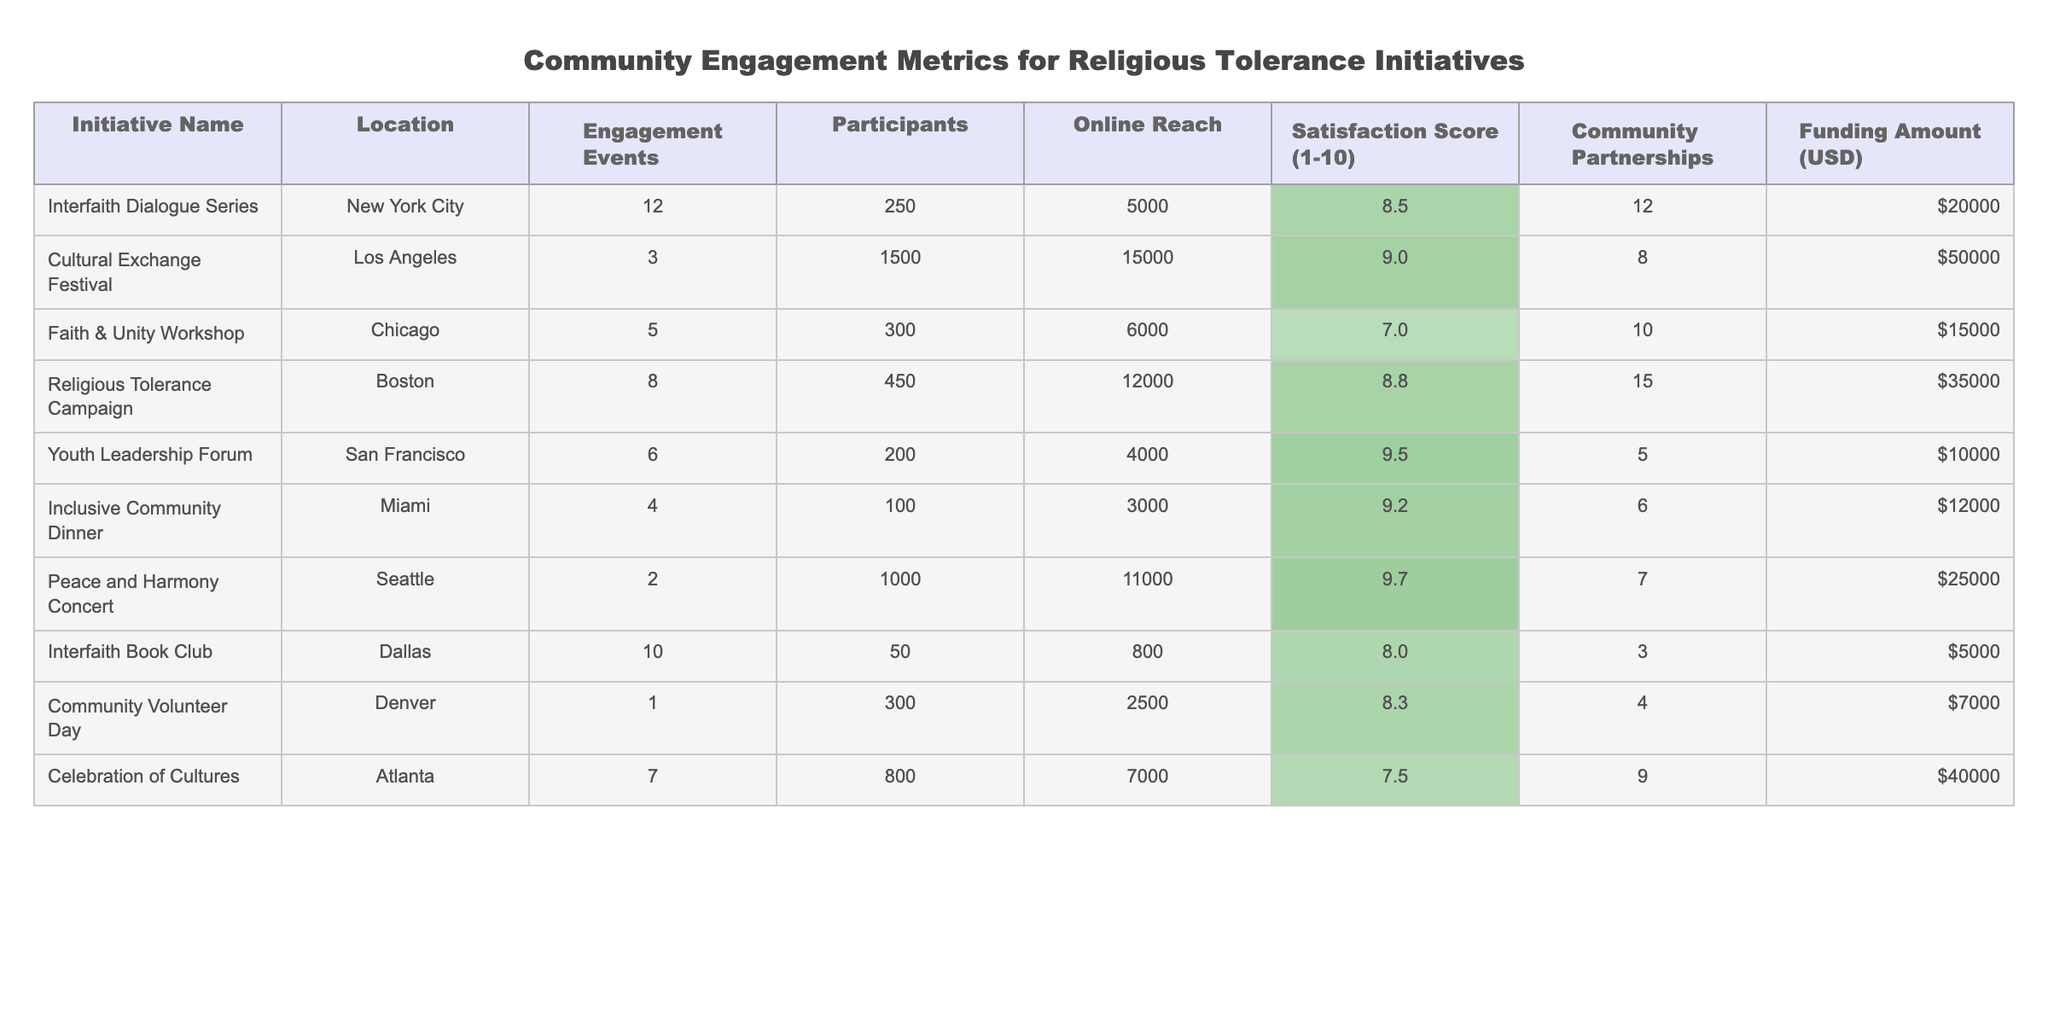What's the highest Satisfaction Score in the table? The Satisfaction Score is listed for each initiative. Scanning through the values, we find that the highest score is 9.7 from the Peace and Harmony Concert.
Answer: 9.7 How many engagement events were held for the Cultural Exchange Festival? The table indicates that the Cultural Exchange Festival has 3 engagement events. Therefore, the answer is directly referenced from the "Engagement Events" column under that initiative.
Answer: 3 What is the total funding amount for all initiatives? To find the total funding amount, I need to sum all the values in the "Funding Amount" column: 20000 + 50000 + 15000 + 35000 + 10000 + 12000 + 25000 + 5000 + 7000 + 40000 = 222000.
Answer: 222000 Which initiative in San Francisco had the highest Satisfaction Score? From the table, the Youth Leadership Forum is the only initiative listed in San Francisco, and its Satisfaction Score is 9.5. Hence there is no comparison needed.
Answer: Yes, the Youth Leadership Forum had a Satisfaction Score of 9.5 Which initiative had the lowest number of participants and what was the Satisfaction Score for that initiative? A review of the "Participants" column shows that the Interfaith Book Club had the lowest number of participants at 50. Its Satisfaction Score is 8.0.
Answer: Interfaith Book Club, Satisfaction Score 8.0 What is the average Satisfaction Score among all initiatives? First, I will add up all the Satisfaction Scores: 8.5 + 9.0 + 7.0 + 8.8 + 9.5 + 9.2 + 9.7 + 8.0 + 8.3 + 7.5 = 88.5. There are 10 initiatives, so the average Satisfaction Score is 88.5/10 = 8.85.
Answer: 8.85 Are there any initiatives with a Satisfaction Score greater than 9? Checking the Satisfaction Score values, I see that the Cultural Exchange Festival, Youth Leadership Forum, Peace and Harmony Concert, and Inclusive Community Dinner all exceed 9. Therefore, the answer to the question is yes.
Answer: Yes Which city had the most community partnerships involved in religious tolerance initiatives? Looking at the "Community Partnerships" column, the Religious Tolerance Campaign in Boston had the highest number of partnerships at 15. This involves simply finding the maximum value in that column.
Answer: Boston with 15 partnerships What is the difference in the number of participants between the Cultural Exchange Festival and the Interfaith Book Club? The Cultural Exchange Festival has 1500 participants, and the Interfaith Book Club has 50 participants. The difference is 1500 - 50 = 1450.
Answer: 1450 Which initiative has the highest online reach and what is that value? Scanning the "Online Reach" column, the Cultural Exchange Festival has the highest online reach at 15000.
Answer: Cultural Exchange Festival, 15000 What was the total number of engagement events conducted in all cities? By adding the values from the "Engagement Events" column: 12 + 3 + 5 + 8 + 6 + 4 + 2 + 10 + 1 + 7 = 58. This provides the total events held across all initiatives.
Answer: 58 